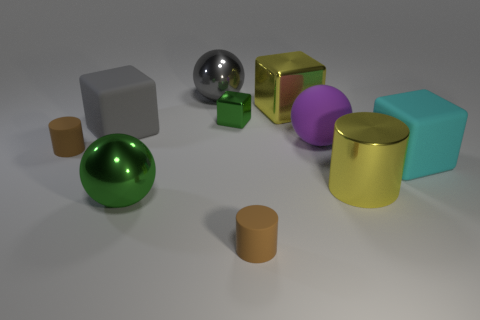Subtract all cubes. How many objects are left? 6 Add 6 small red rubber things. How many small red rubber things exist? 6 Subtract 0 blue cylinders. How many objects are left? 10 Subtract all big cyan cylinders. Subtract all brown rubber cylinders. How many objects are left? 8 Add 4 tiny brown matte things. How many tiny brown matte things are left? 6 